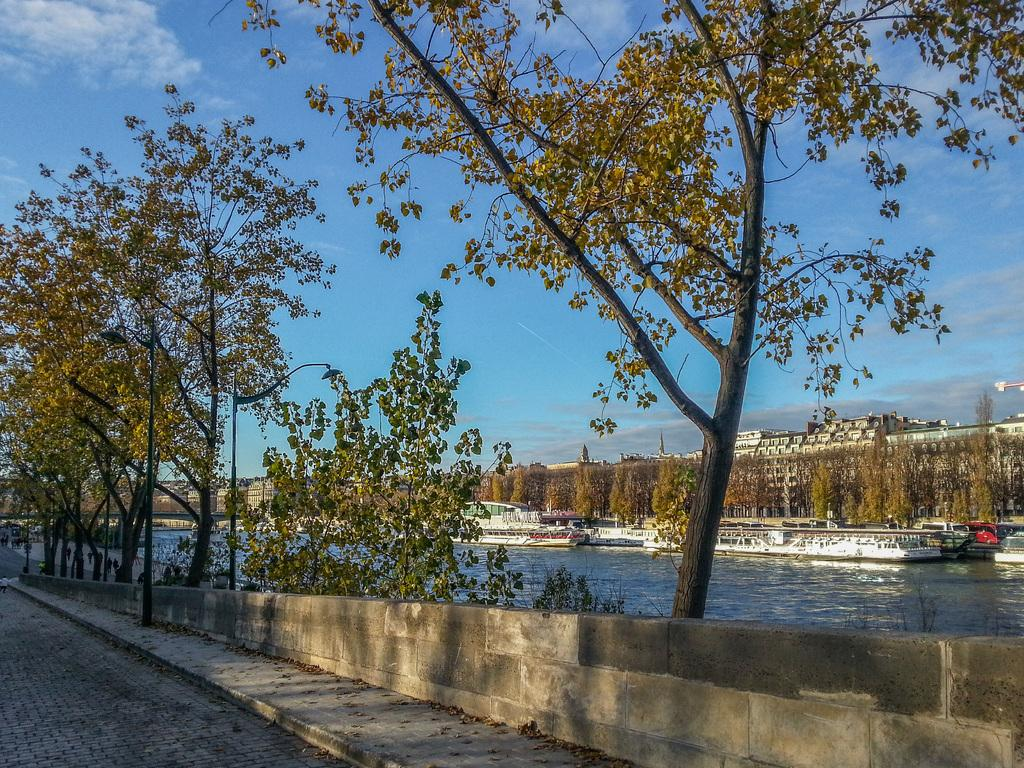What type of natural elements can be seen in the image? There are trees in the image. What man-made structures are present in the image? There is a road, a wall, and buildings in the image. What can be seen in the background of the image? In the background, there are boats on water, buildings, and the sky. What type of disgust can be seen on the toad's face in the image? There is: There is no toad present in the image, and therefore no facial expressions or emotions can be observed. 